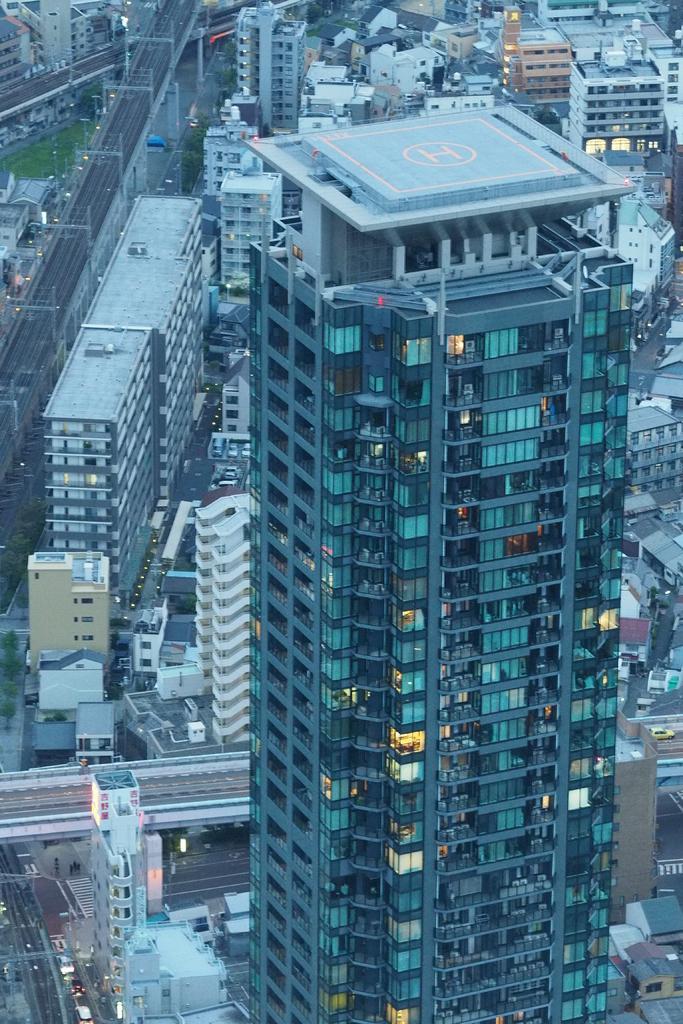Can you describe this image briefly? In this picture I can see number of buildings and I can see the roads, on which there are vehicles and on the left side of this picture I can see few poles and I can also see the lights on few buildings and in the center of this picture I can see a helipad on a building. 